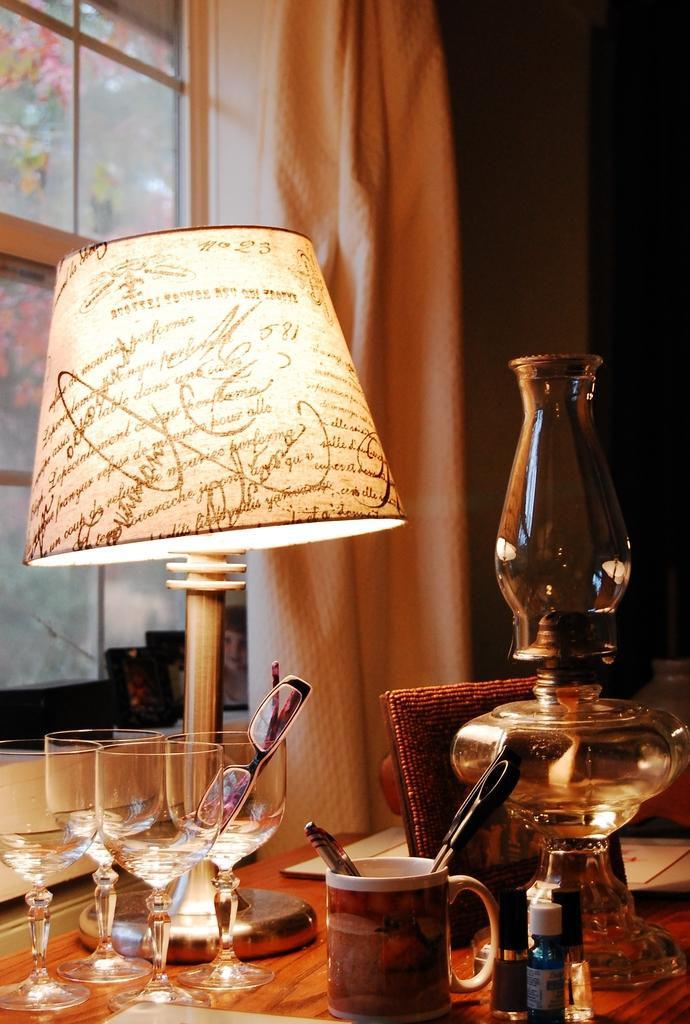What is the main object in the center of the image? There is a table in the center of the image. What items can be seen on the table? On the table, there are glasses, a mug, a knife, a chimney, a plate, and a lamp. What is visible in the background of the image? There is a wall, a window, and a curtain associated with the window in the background of the image. What type of prose can be seen on the table in the image? There is no prose present on the table in the image. Can you see any deer in the image? There are no deer present in the image. 